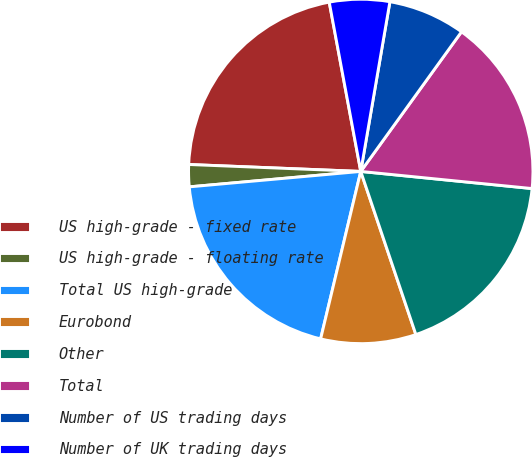Convert chart to OTSL. <chart><loc_0><loc_0><loc_500><loc_500><pie_chart><fcel>US high-grade - fixed rate<fcel>US high-grade - floating rate<fcel>Total US high-grade<fcel>Eurobond<fcel>Other<fcel>Total<fcel>Number of US trading days<fcel>Number of UK trading days<nl><fcel>21.43%<fcel>2.07%<fcel>19.83%<fcel>8.93%<fcel>18.23%<fcel>16.64%<fcel>7.24%<fcel>5.64%<nl></chart> 